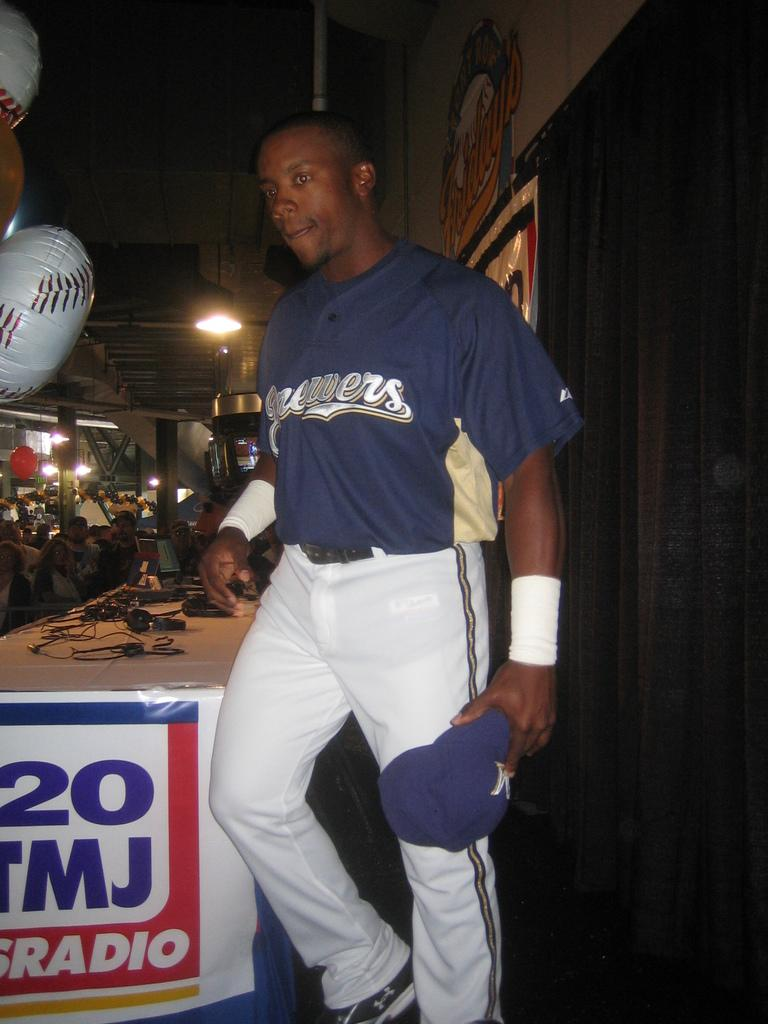<image>
Offer a succinct explanation of the picture presented. A man wears a jersey bearing the name Brewers. 